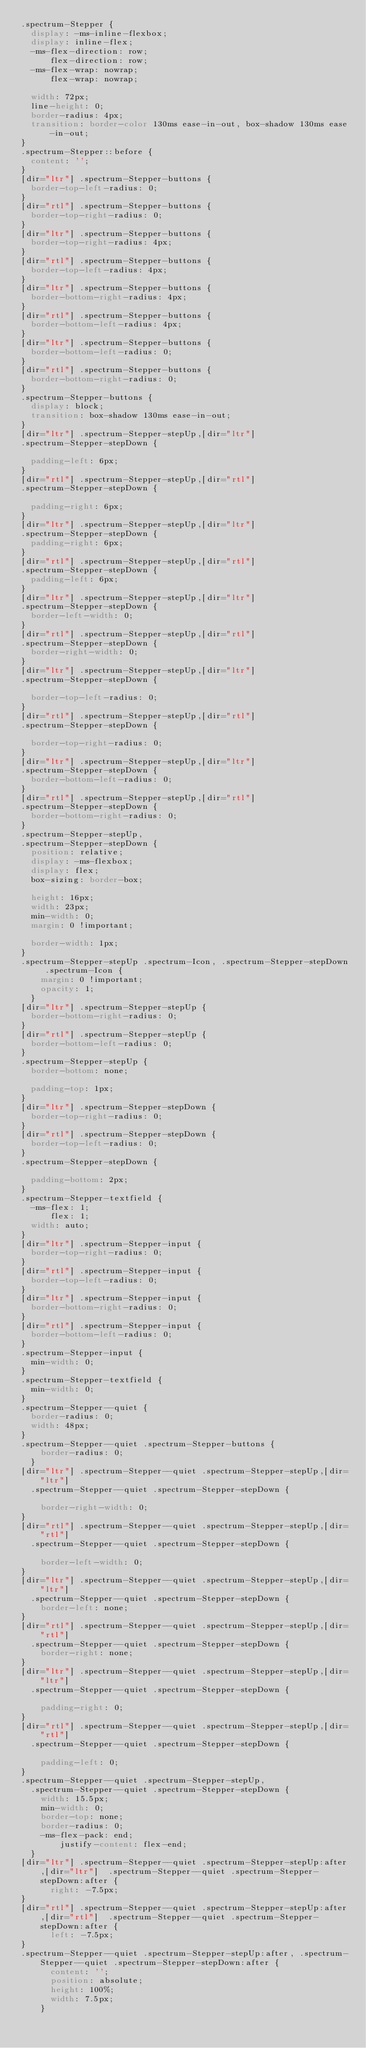<code> <loc_0><loc_0><loc_500><loc_500><_CSS_>.spectrum-Stepper {
  display: -ms-inline-flexbox;
  display: inline-flex;
  -ms-flex-direction: row;
      flex-direction: row;
  -ms-flex-wrap: nowrap;
      flex-wrap: nowrap;

  width: 72px;
  line-height: 0;
  border-radius: 4px;
  transition: border-color 130ms ease-in-out, box-shadow 130ms ease-in-out;
}
.spectrum-Stepper::before {
  content: '';
}
[dir="ltr"] .spectrum-Stepper-buttons {
  border-top-left-radius: 0;
}
[dir="rtl"] .spectrum-Stepper-buttons {
  border-top-right-radius: 0;
}
[dir="ltr"] .spectrum-Stepper-buttons {
  border-top-right-radius: 4px;
}
[dir="rtl"] .spectrum-Stepper-buttons {
  border-top-left-radius: 4px;
}
[dir="ltr"] .spectrum-Stepper-buttons {
  border-bottom-right-radius: 4px;
}
[dir="rtl"] .spectrum-Stepper-buttons {
  border-bottom-left-radius: 4px;
}
[dir="ltr"] .spectrum-Stepper-buttons {
  border-bottom-left-radius: 0;
}
[dir="rtl"] .spectrum-Stepper-buttons {
  border-bottom-right-radius: 0;
}
.spectrum-Stepper-buttons {
  display: block;
  transition: box-shadow 130ms ease-in-out;
}
[dir="ltr"] .spectrum-Stepper-stepUp,[dir="ltr"] 
.spectrum-Stepper-stepDown {

  padding-left: 6px;
}
[dir="rtl"] .spectrum-Stepper-stepUp,[dir="rtl"] 
.spectrum-Stepper-stepDown {

  padding-right: 6px;
}
[dir="ltr"] .spectrum-Stepper-stepUp,[dir="ltr"] 
.spectrum-Stepper-stepDown {
  padding-right: 6px;
}
[dir="rtl"] .spectrum-Stepper-stepUp,[dir="rtl"] 
.spectrum-Stepper-stepDown {
  padding-left: 6px;
}
[dir="ltr"] .spectrum-Stepper-stepUp,[dir="ltr"] 
.spectrum-Stepper-stepDown {
  border-left-width: 0;
}
[dir="rtl"] .spectrum-Stepper-stepUp,[dir="rtl"] 
.spectrum-Stepper-stepDown {
  border-right-width: 0;
}
[dir="ltr"] .spectrum-Stepper-stepUp,[dir="ltr"] 
.spectrum-Stepper-stepDown {

  border-top-left-radius: 0;
}
[dir="rtl"] .spectrum-Stepper-stepUp,[dir="rtl"] 
.spectrum-Stepper-stepDown {

  border-top-right-radius: 0;
}
[dir="ltr"] .spectrum-Stepper-stepUp,[dir="ltr"] 
.spectrum-Stepper-stepDown {
  border-bottom-left-radius: 0;
}
[dir="rtl"] .spectrum-Stepper-stepUp,[dir="rtl"] 
.spectrum-Stepper-stepDown {
  border-bottom-right-radius: 0;
}
.spectrum-Stepper-stepUp,
.spectrum-Stepper-stepDown {
  position: relative;
  display: -ms-flexbox;
  display: flex;
  box-sizing: border-box;

  height: 16px;
  width: 23px;
  min-width: 0;
  margin: 0 !important;

  border-width: 1px;
}
.spectrum-Stepper-stepUp .spectrum-Icon, .spectrum-Stepper-stepDown .spectrum-Icon {
    margin: 0 !important;
    opacity: 1;
  }
[dir="ltr"] .spectrum-Stepper-stepUp {
  border-bottom-right-radius: 0;
}
[dir="rtl"] .spectrum-Stepper-stepUp {
  border-bottom-left-radius: 0;
}
.spectrum-Stepper-stepUp {
  border-bottom: none;

  padding-top: 1px;
}
[dir="ltr"] .spectrum-Stepper-stepDown {
  border-top-right-radius: 0;
}
[dir="rtl"] .spectrum-Stepper-stepDown {
  border-top-left-radius: 0;
}
.spectrum-Stepper-stepDown {

  padding-bottom: 2px;
}
.spectrum-Stepper-textfield {
  -ms-flex: 1;
      flex: 1;
  width: auto;
}
[dir="ltr"] .spectrum-Stepper-input {
  border-top-right-radius: 0;
}
[dir="rtl"] .spectrum-Stepper-input {
  border-top-left-radius: 0;
}
[dir="ltr"] .spectrum-Stepper-input {
  border-bottom-right-radius: 0;
}
[dir="rtl"] .spectrum-Stepper-input {
  border-bottom-left-radius: 0;
}
.spectrum-Stepper-input {
  min-width: 0;
}
.spectrum-Stepper-textfield {
  min-width: 0;
}
.spectrum-Stepper--quiet {
  border-radius: 0;
  width: 48px;
}
.spectrum-Stepper--quiet .spectrum-Stepper-buttons {
    border-radius: 0;
  }
[dir="ltr"] .spectrum-Stepper--quiet .spectrum-Stepper-stepUp,[dir="ltr"] 
  .spectrum-Stepper--quiet .spectrum-Stepper-stepDown {

    border-right-width: 0;
}
[dir="rtl"] .spectrum-Stepper--quiet .spectrum-Stepper-stepUp,[dir="rtl"] 
  .spectrum-Stepper--quiet .spectrum-Stepper-stepDown {

    border-left-width: 0;
}
[dir="ltr"] .spectrum-Stepper--quiet .spectrum-Stepper-stepUp,[dir="ltr"] 
  .spectrum-Stepper--quiet .spectrum-Stepper-stepDown {
    border-left: none;
}
[dir="rtl"] .spectrum-Stepper--quiet .spectrum-Stepper-stepUp,[dir="rtl"] 
  .spectrum-Stepper--quiet .spectrum-Stepper-stepDown {
    border-right: none;
}
[dir="ltr"] .spectrum-Stepper--quiet .spectrum-Stepper-stepUp,[dir="ltr"] 
  .spectrum-Stepper--quiet .spectrum-Stepper-stepDown {

    padding-right: 0;
}
[dir="rtl"] .spectrum-Stepper--quiet .spectrum-Stepper-stepUp,[dir="rtl"] 
  .spectrum-Stepper--quiet .spectrum-Stepper-stepDown {

    padding-left: 0;
}
.spectrum-Stepper--quiet .spectrum-Stepper-stepUp,
  .spectrum-Stepper--quiet .spectrum-Stepper-stepDown {
    width: 15.5px;
    min-width: 0;
    border-top: none;
    border-radius: 0;
    -ms-flex-pack: end;
        justify-content: flex-end;
  }
[dir="ltr"] .spectrum-Stepper--quiet .spectrum-Stepper-stepUp:after,[dir="ltr"]  .spectrum-Stepper--quiet .spectrum-Stepper-stepDown:after {
      right: -7.5px;
}
[dir="rtl"] .spectrum-Stepper--quiet .spectrum-Stepper-stepUp:after,[dir="rtl"]  .spectrum-Stepper--quiet .spectrum-Stepper-stepDown:after {
      left: -7.5px;
}
.spectrum-Stepper--quiet .spectrum-Stepper-stepUp:after, .spectrum-Stepper--quiet .spectrum-Stepper-stepDown:after {
      content: '';
      position: absolute;
      height: 100%;
      width: 7.5px;
    }
</code> 